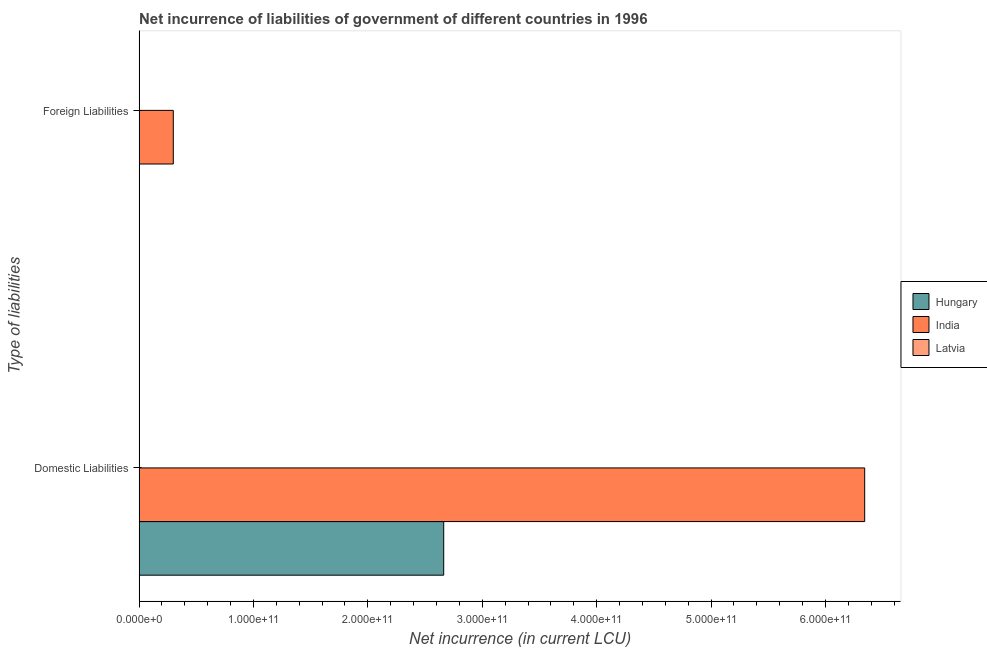How many different coloured bars are there?
Provide a succinct answer. 3. How many groups of bars are there?
Ensure brevity in your answer.  2. How many bars are there on the 1st tick from the top?
Provide a short and direct response. 2. How many bars are there on the 1st tick from the bottom?
Your answer should be compact. 3. What is the label of the 2nd group of bars from the top?
Your answer should be very brief. Domestic Liabilities. What is the net incurrence of domestic liabilities in Latvia?
Ensure brevity in your answer.  4.12e+07. Across all countries, what is the maximum net incurrence of foreign liabilities?
Your answer should be compact. 2.99e+1. Across all countries, what is the minimum net incurrence of domestic liabilities?
Keep it short and to the point. 4.12e+07. In which country was the net incurrence of foreign liabilities maximum?
Provide a succinct answer. India. What is the total net incurrence of foreign liabilities in the graph?
Make the answer very short. 2.99e+1. What is the difference between the net incurrence of domestic liabilities in Hungary and that in Latvia?
Make the answer very short. 2.66e+11. What is the difference between the net incurrence of foreign liabilities in India and the net incurrence of domestic liabilities in Latvia?
Provide a short and direct response. 2.99e+1. What is the average net incurrence of foreign liabilities per country?
Your response must be concise. 9.97e+09. What is the difference between the net incurrence of foreign liabilities and net incurrence of domestic liabilities in Latvia?
Make the answer very short. -2.06e+07. In how many countries, is the net incurrence of domestic liabilities greater than 380000000000 LCU?
Give a very brief answer. 1. What is the ratio of the net incurrence of domestic liabilities in India to that in Latvia?
Give a very brief answer. 1.54e+04. Is the net incurrence of domestic liabilities in Hungary less than that in Latvia?
Provide a short and direct response. No. How many bars are there?
Your response must be concise. 5. What is the difference between two consecutive major ticks on the X-axis?
Make the answer very short. 1.00e+11. Does the graph contain grids?
Your response must be concise. No. Where does the legend appear in the graph?
Offer a terse response. Center right. How are the legend labels stacked?
Offer a terse response. Vertical. What is the title of the graph?
Make the answer very short. Net incurrence of liabilities of government of different countries in 1996. Does "Sao Tome and Principe" appear as one of the legend labels in the graph?
Make the answer very short. No. What is the label or title of the X-axis?
Your answer should be compact. Net incurrence (in current LCU). What is the label or title of the Y-axis?
Your response must be concise. Type of liabilities. What is the Net incurrence (in current LCU) of Hungary in Domestic Liabilities?
Ensure brevity in your answer.  2.66e+11. What is the Net incurrence (in current LCU) in India in Domestic Liabilities?
Your answer should be compact. 6.34e+11. What is the Net incurrence (in current LCU) of Latvia in Domestic Liabilities?
Give a very brief answer. 4.12e+07. What is the Net incurrence (in current LCU) in India in Foreign Liabilities?
Give a very brief answer. 2.99e+1. What is the Net incurrence (in current LCU) of Latvia in Foreign Liabilities?
Your answer should be very brief. 2.06e+07. Across all Type of liabilities, what is the maximum Net incurrence (in current LCU) of Hungary?
Offer a very short reply. 2.66e+11. Across all Type of liabilities, what is the maximum Net incurrence (in current LCU) of India?
Make the answer very short. 6.34e+11. Across all Type of liabilities, what is the maximum Net incurrence (in current LCU) of Latvia?
Offer a terse response. 4.12e+07. Across all Type of liabilities, what is the minimum Net incurrence (in current LCU) of India?
Provide a short and direct response. 2.99e+1. Across all Type of liabilities, what is the minimum Net incurrence (in current LCU) of Latvia?
Offer a terse response. 2.06e+07. What is the total Net incurrence (in current LCU) in Hungary in the graph?
Make the answer very short. 2.66e+11. What is the total Net incurrence (in current LCU) in India in the graph?
Provide a short and direct response. 6.64e+11. What is the total Net incurrence (in current LCU) in Latvia in the graph?
Make the answer very short. 6.18e+07. What is the difference between the Net incurrence (in current LCU) of India in Domestic Liabilities and that in Foreign Liabilities?
Your answer should be compact. 6.04e+11. What is the difference between the Net incurrence (in current LCU) of Latvia in Domestic Liabilities and that in Foreign Liabilities?
Give a very brief answer. 2.06e+07. What is the difference between the Net incurrence (in current LCU) of Hungary in Domestic Liabilities and the Net incurrence (in current LCU) of India in Foreign Liabilities?
Ensure brevity in your answer.  2.36e+11. What is the difference between the Net incurrence (in current LCU) of Hungary in Domestic Liabilities and the Net incurrence (in current LCU) of Latvia in Foreign Liabilities?
Provide a short and direct response. 2.66e+11. What is the difference between the Net incurrence (in current LCU) of India in Domestic Liabilities and the Net incurrence (in current LCU) of Latvia in Foreign Liabilities?
Make the answer very short. 6.34e+11. What is the average Net incurrence (in current LCU) of Hungary per Type of liabilities?
Keep it short and to the point. 1.33e+11. What is the average Net incurrence (in current LCU) in India per Type of liabilities?
Your answer should be very brief. 3.32e+11. What is the average Net incurrence (in current LCU) of Latvia per Type of liabilities?
Give a very brief answer. 3.09e+07. What is the difference between the Net incurrence (in current LCU) in Hungary and Net incurrence (in current LCU) in India in Domestic Liabilities?
Your answer should be very brief. -3.68e+11. What is the difference between the Net incurrence (in current LCU) of Hungary and Net incurrence (in current LCU) of Latvia in Domestic Liabilities?
Provide a succinct answer. 2.66e+11. What is the difference between the Net incurrence (in current LCU) in India and Net incurrence (in current LCU) in Latvia in Domestic Liabilities?
Make the answer very short. 6.34e+11. What is the difference between the Net incurrence (in current LCU) of India and Net incurrence (in current LCU) of Latvia in Foreign Liabilities?
Provide a short and direct response. 2.99e+1. What is the ratio of the Net incurrence (in current LCU) of India in Domestic Liabilities to that in Foreign Liabilities?
Your response must be concise. 21.22. What is the ratio of the Net incurrence (in current LCU) in Latvia in Domestic Liabilities to that in Foreign Liabilities?
Offer a terse response. 2. What is the difference between the highest and the second highest Net incurrence (in current LCU) in India?
Give a very brief answer. 6.04e+11. What is the difference between the highest and the second highest Net incurrence (in current LCU) in Latvia?
Your response must be concise. 2.06e+07. What is the difference between the highest and the lowest Net incurrence (in current LCU) of Hungary?
Your response must be concise. 2.66e+11. What is the difference between the highest and the lowest Net incurrence (in current LCU) in India?
Offer a terse response. 6.04e+11. What is the difference between the highest and the lowest Net incurrence (in current LCU) of Latvia?
Keep it short and to the point. 2.06e+07. 